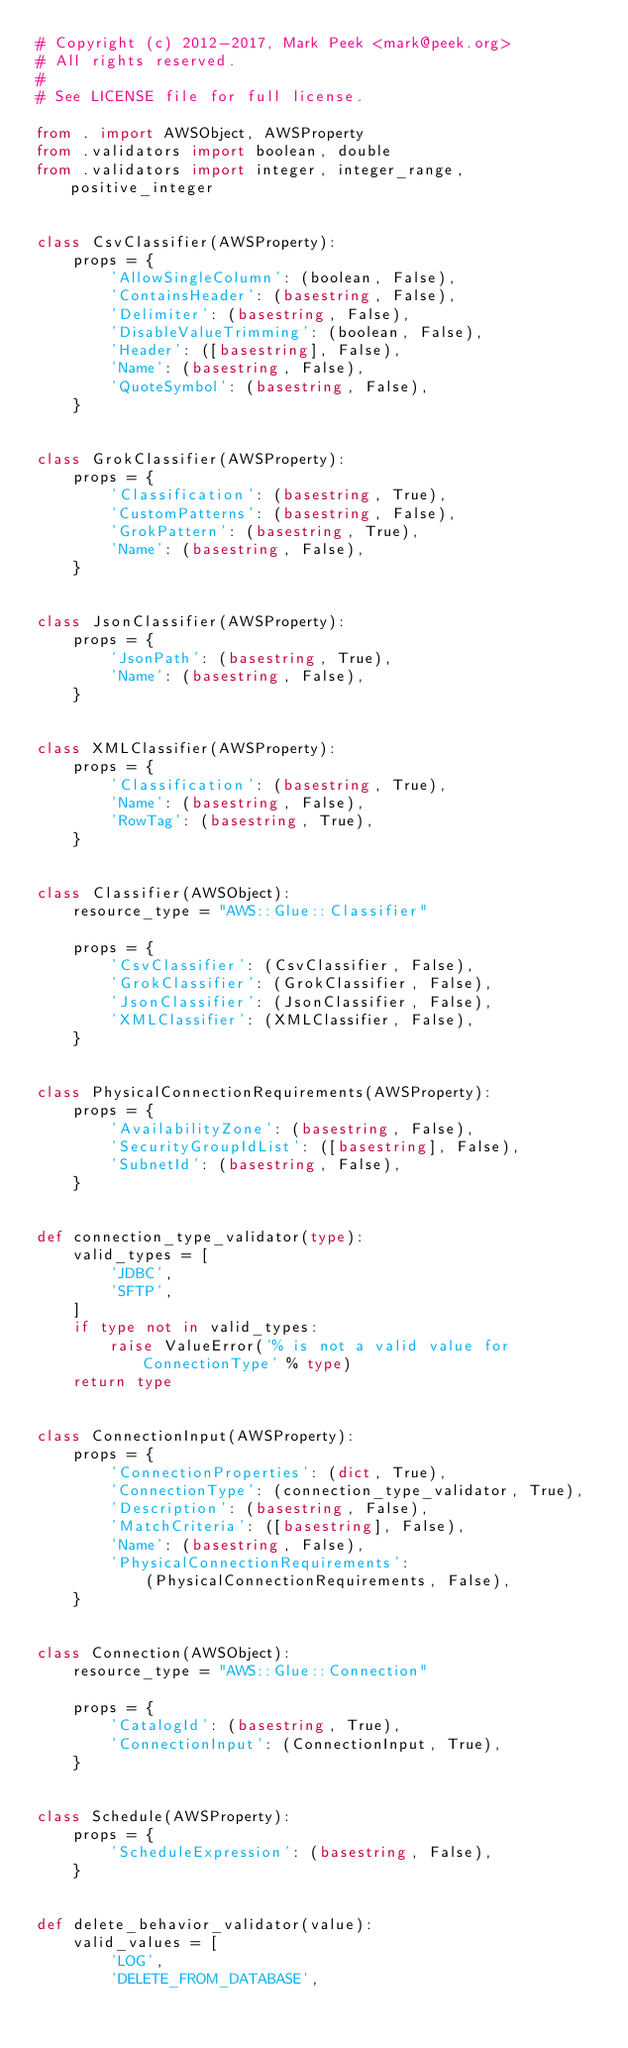Convert code to text. <code><loc_0><loc_0><loc_500><loc_500><_Python_># Copyright (c) 2012-2017, Mark Peek <mark@peek.org>
# All rights reserved.
#
# See LICENSE file for full license.

from . import AWSObject, AWSProperty
from .validators import boolean, double
from .validators import integer, integer_range, positive_integer


class CsvClassifier(AWSProperty):
    props = {
        'AllowSingleColumn': (boolean, False),
        'ContainsHeader': (basestring, False),
        'Delimiter': (basestring, False),
        'DisableValueTrimming': (boolean, False),
        'Header': ([basestring], False),
        'Name': (basestring, False),
        'QuoteSymbol': (basestring, False),
    }


class GrokClassifier(AWSProperty):
    props = {
        'Classification': (basestring, True),
        'CustomPatterns': (basestring, False),
        'GrokPattern': (basestring, True),
        'Name': (basestring, False),
    }


class JsonClassifier(AWSProperty):
    props = {
        'JsonPath': (basestring, True),
        'Name': (basestring, False),
    }


class XMLClassifier(AWSProperty):
    props = {
        'Classification': (basestring, True),
        'Name': (basestring, False),
        'RowTag': (basestring, True),
    }


class Classifier(AWSObject):
    resource_type = "AWS::Glue::Classifier"

    props = {
        'CsvClassifier': (CsvClassifier, False),
        'GrokClassifier': (GrokClassifier, False),
        'JsonClassifier': (JsonClassifier, False),
        'XMLClassifier': (XMLClassifier, False),
    }


class PhysicalConnectionRequirements(AWSProperty):
    props = {
        'AvailabilityZone': (basestring, False),
        'SecurityGroupIdList': ([basestring], False),
        'SubnetId': (basestring, False),
    }


def connection_type_validator(type):
    valid_types = [
        'JDBC',
        'SFTP',
    ]
    if type not in valid_types:
        raise ValueError('% is not a valid value for ConnectionType' % type)
    return type


class ConnectionInput(AWSProperty):
    props = {
        'ConnectionProperties': (dict, True),
        'ConnectionType': (connection_type_validator, True),
        'Description': (basestring, False),
        'MatchCriteria': ([basestring], False),
        'Name': (basestring, False),
        'PhysicalConnectionRequirements':
            (PhysicalConnectionRequirements, False),
    }


class Connection(AWSObject):
    resource_type = "AWS::Glue::Connection"

    props = {
        'CatalogId': (basestring, True),
        'ConnectionInput': (ConnectionInput, True),
    }


class Schedule(AWSProperty):
    props = {
        'ScheduleExpression': (basestring, False),
    }


def delete_behavior_validator(value):
    valid_values = [
        'LOG',
        'DELETE_FROM_DATABASE',</code> 